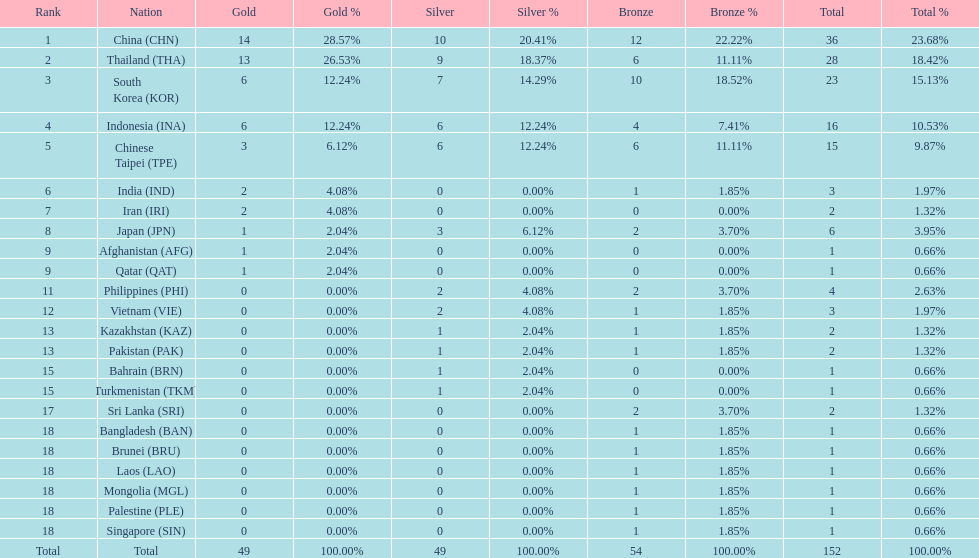Could you parse the entire table as a dict? {'header': ['Rank', 'Nation', 'Gold', 'Gold %', 'Silver', 'Silver %', 'Bronze', 'Bronze %', 'Total', 'Total %'], 'rows': [['1', 'China\xa0(CHN)', '14', '28.57%', '10', '20.41%', '12', '22.22%', '36', '23.68%'], ['2', 'Thailand\xa0(THA)', '13', '26.53%', '9', '18.37%', '6', '11.11%', '28', '18.42%'], ['3', 'South Korea\xa0(KOR)', '6', '12.24%', '7', '14.29%', '10', '18.52%', '23', '15.13%'], ['4', 'Indonesia\xa0(INA)', '6', '12.24%', '6', '12.24%', '4', '7.41%', '16', '10.53%'], ['5', 'Chinese Taipei\xa0(TPE)', '3', '6.12%', '6', '12.24%', '6', '11.11%', '15', '9.87%'], ['6', 'India\xa0(IND)', '2', '4.08%', '0', '0.00%', '1', '1.85%', '3', '1.97%'], ['7', 'Iran\xa0(IRI)', '2', '4.08%', '0', '0.00%', '0', '0.00%', '2', '1.32%'], ['8', 'Japan\xa0(JPN)', '1', '2.04%', '3', '6.12%', '2', '3.70%', '6', '3.95%'], ['9', 'Afghanistan\xa0(AFG)', '1', '2.04%', '0', '0.00%', '0', '0.00%', '1', '0.66%'], ['9', 'Qatar\xa0(QAT)', '1', '2.04%', '0', '0.00%', '0', '0.00%', '1', '0.66%'], ['11', 'Philippines\xa0(PHI)', '0', '0.00%', '2', '4.08%', '2', '3.70%', '4', '2.63%'], ['12', 'Vietnam\xa0(VIE)', '0', '0.00%', '2', '4.08%', '1', '1.85%', '3', '1.97%'], ['13', 'Kazakhstan\xa0(KAZ)', '0', '0.00%', '1', '2.04%', '1', '1.85%', '2', '1.32%'], ['13', 'Pakistan\xa0(PAK)', '0', '0.00%', '1', '2.04%', '1', '1.85%', '2', '1.32%'], ['15', 'Bahrain\xa0(BRN)', '0', '0.00%', '1', '2.04%', '0', '0.00%', '1', '0.66%'], ['15', 'Turkmenistan\xa0(TKM)', '0', '0.00%', '1', '2.04%', '0', '0.00%', '1', '0.66%'], ['17', 'Sri Lanka\xa0(SRI)', '0', '0.00%', '0', '0.00%', '2', '3.70%', '2', '1.32%'], ['18', 'Bangladesh\xa0(BAN)', '0', '0.00%', '0', '0.00%', '1', '1.85%', '1', '0.66%'], ['18', 'Brunei\xa0(BRU)', '0', '0.00%', '0', '0.00%', '1', '1.85%', '1', '0.66%'], ['18', 'Laos\xa0(LAO)', '0', '0.00%', '0', '0.00%', '1', '1.85%', '1', '0.66%'], ['18', 'Mongolia\xa0(MGL)', '0', '0.00%', '0', '0.00%', '1', '1.85%', '1', '0.66%'], ['18', 'Palestine\xa0(PLE)', '0', '0.00%', '0', '0.00%', '1', '1.85%', '1', '0.66%'], ['18', 'Singapore\xa0(SIN)', '0', '0.00%', '0', '0.00%', '1', '1.85%', '1', '0.66%'], ['Total', 'Total', '49', '100.00%', '49', '100.00%', '54', '100.00%', '152', '100.00%']]} What was the number of medals earned by indonesia (ina) ? 16. 